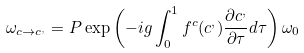<formula> <loc_0><loc_0><loc_500><loc_500>\omega _ { c \rightarrow c ^ { , } } = P \exp \left ( - i g \int _ { 0 } ^ { 1 } f ^ { c } ( c ^ { , } ) \frac { \partial c ^ { , } } { \partial \tau } d \tau \right ) \omega _ { 0 }</formula> 